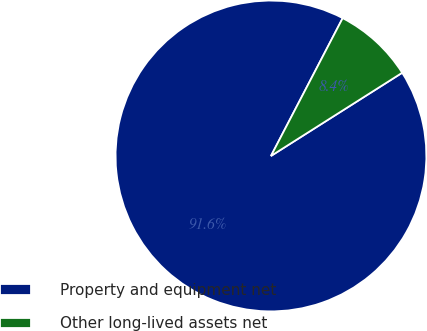<chart> <loc_0><loc_0><loc_500><loc_500><pie_chart><fcel>Property and equipment net<fcel>Other long-lived assets net<nl><fcel>91.63%<fcel>8.37%<nl></chart> 